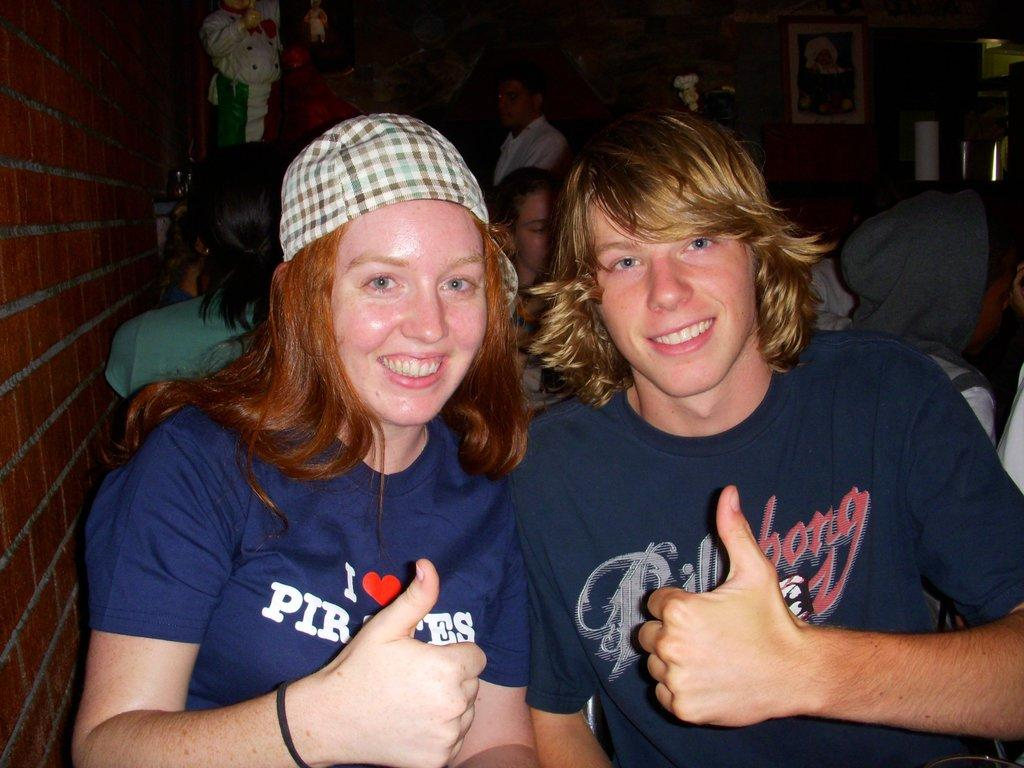How many people are in the foreground of the image? There are two people in the foreground of the image. What are the two people in the foreground doing? The two people in the foreground are posing for a photo. Can you describe the background of the image? There are many other people visible in the image. What is located on the left side of the image? There is a brick wall on the left side of the image. What type of rice can be seen in the image? There is no rice present in the image. Can you describe the flock of birds visible in the image? There are no birds or flocks visible in the image. 